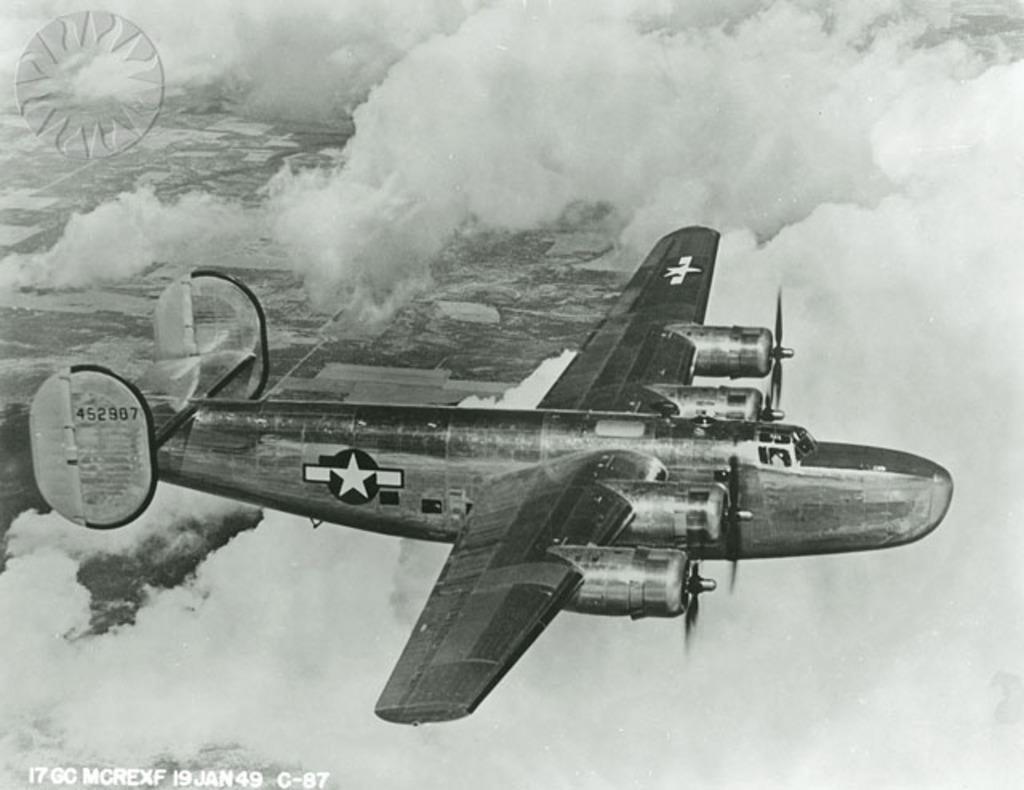<image>
Provide a brief description of the given image. An plane has the numbers 452987 painted on its tailfin. 